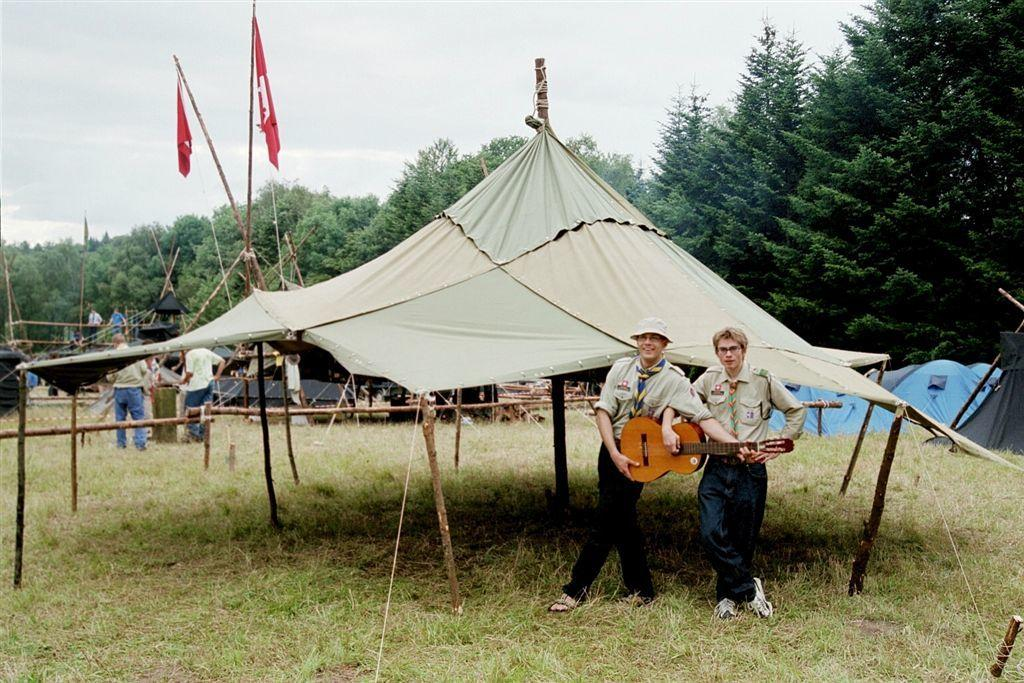What are the people in the image doing? The people in the image are standing on the grass. What are the people holding in their hands? The people are holding objects. What can be seen in the background of the image? There are tents visible in the background. What type of natural environment is present in the image? Trees are present around the area. What type of crime is being committed in the image? There is no indication of any crime being committed in the image. Can you tell me how many bikes are present in the image? There are no bikes visible in the image. 